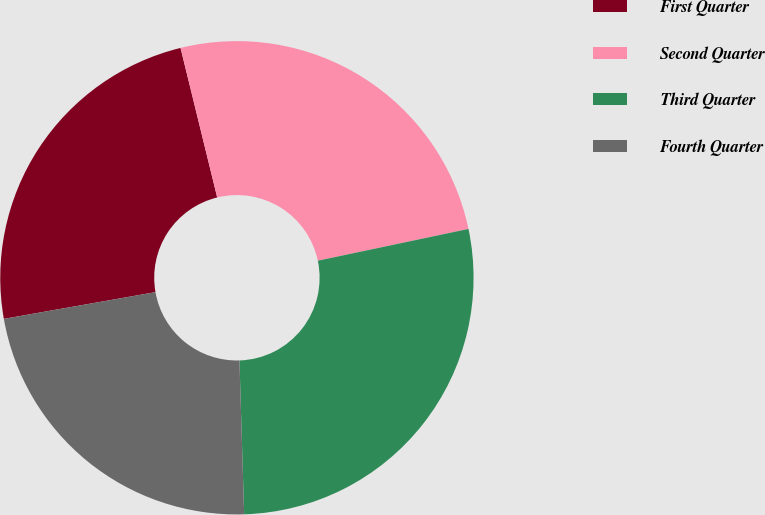Convert chart. <chart><loc_0><loc_0><loc_500><loc_500><pie_chart><fcel>First Quarter<fcel>Second Quarter<fcel>Third Quarter<fcel>Fourth Quarter<nl><fcel>23.95%<fcel>25.52%<fcel>27.82%<fcel>22.71%<nl></chart> 